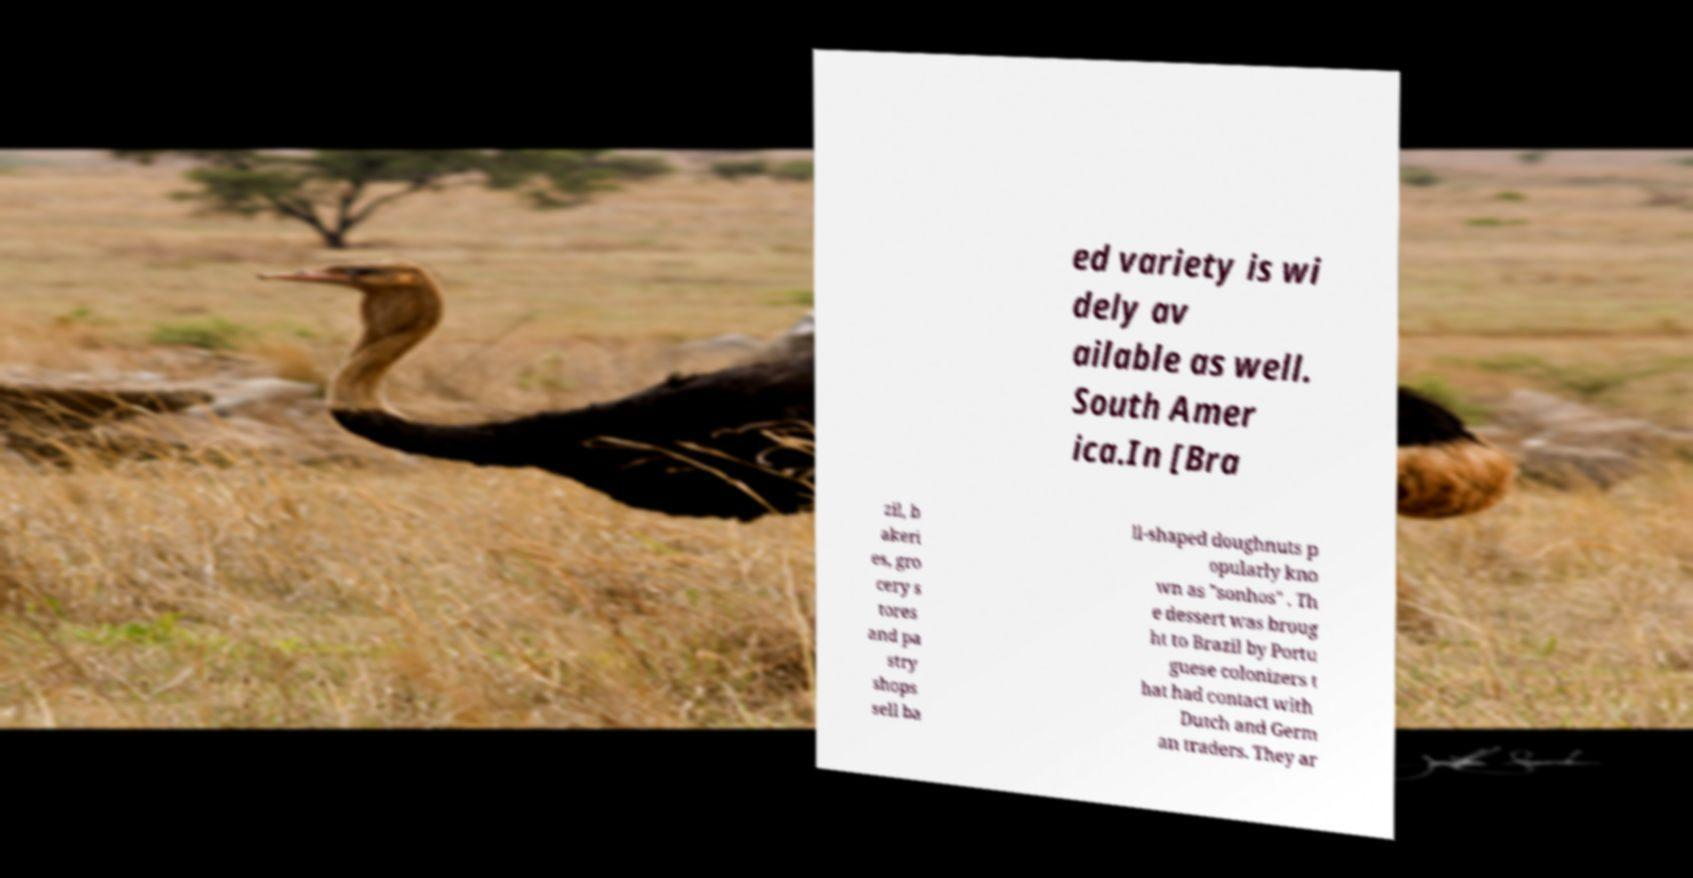Please read and relay the text visible in this image. What does it say? ed variety is wi dely av ailable as well. South Amer ica.In [Bra zil, b akeri es, gro cery s tores and pa stry shops sell ba ll-shaped doughnuts p opularly kno wn as "sonhos" . Th e dessert was broug ht to Brazil by Portu guese colonizers t hat had contact with Dutch and Germ an traders. They ar 